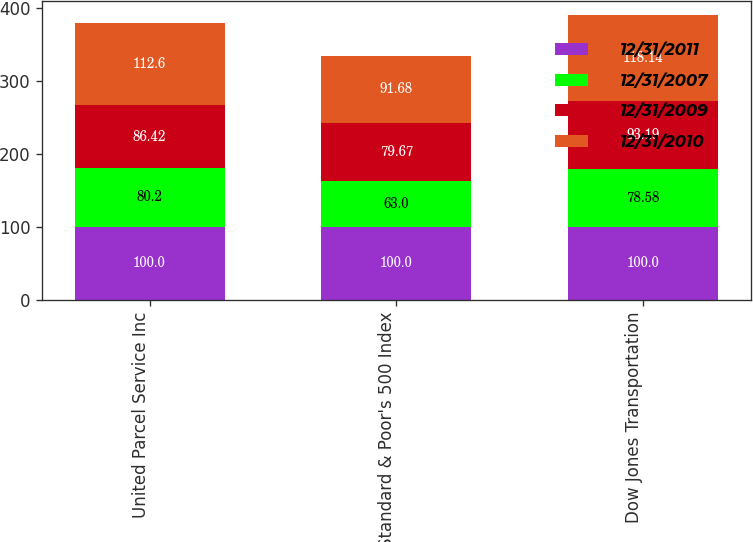Convert chart to OTSL. <chart><loc_0><loc_0><loc_500><loc_500><stacked_bar_chart><ecel><fcel>United Parcel Service Inc<fcel>Standard & Poor's 500 Index<fcel>Dow Jones Transportation<nl><fcel>12/31/2011<fcel>100<fcel>100<fcel>100<nl><fcel>12/31/2007<fcel>80.2<fcel>63<fcel>78.58<nl><fcel>12/31/2009<fcel>86.42<fcel>79.67<fcel>93.19<nl><fcel>12/31/2010<fcel>112.6<fcel>91.68<fcel>118.14<nl></chart> 